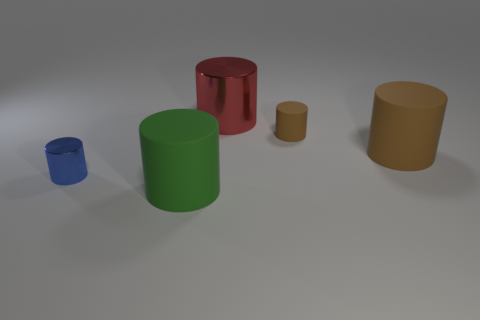Subtract all large green cylinders. How many cylinders are left? 4 Subtract all brown spheres. How many brown cylinders are left? 2 Subtract all red cylinders. How many cylinders are left? 4 Add 2 tiny cyan things. How many objects exist? 7 Subtract 2 cylinders. How many cylinders are left? 3 Subtract 0 brown cubes. How many objects are left? 5 Subtract all gray cylinders. Subtract all gray blocks. How many cylinders are left? 5 Subtract all green cylinders. Subtract all brown matte objects. How many objects are left? 2 Add 4 tiny blue cylinders. How many tiny blue cylinders are left? 5 Add 2 spheres. How many spheres exist? 2 